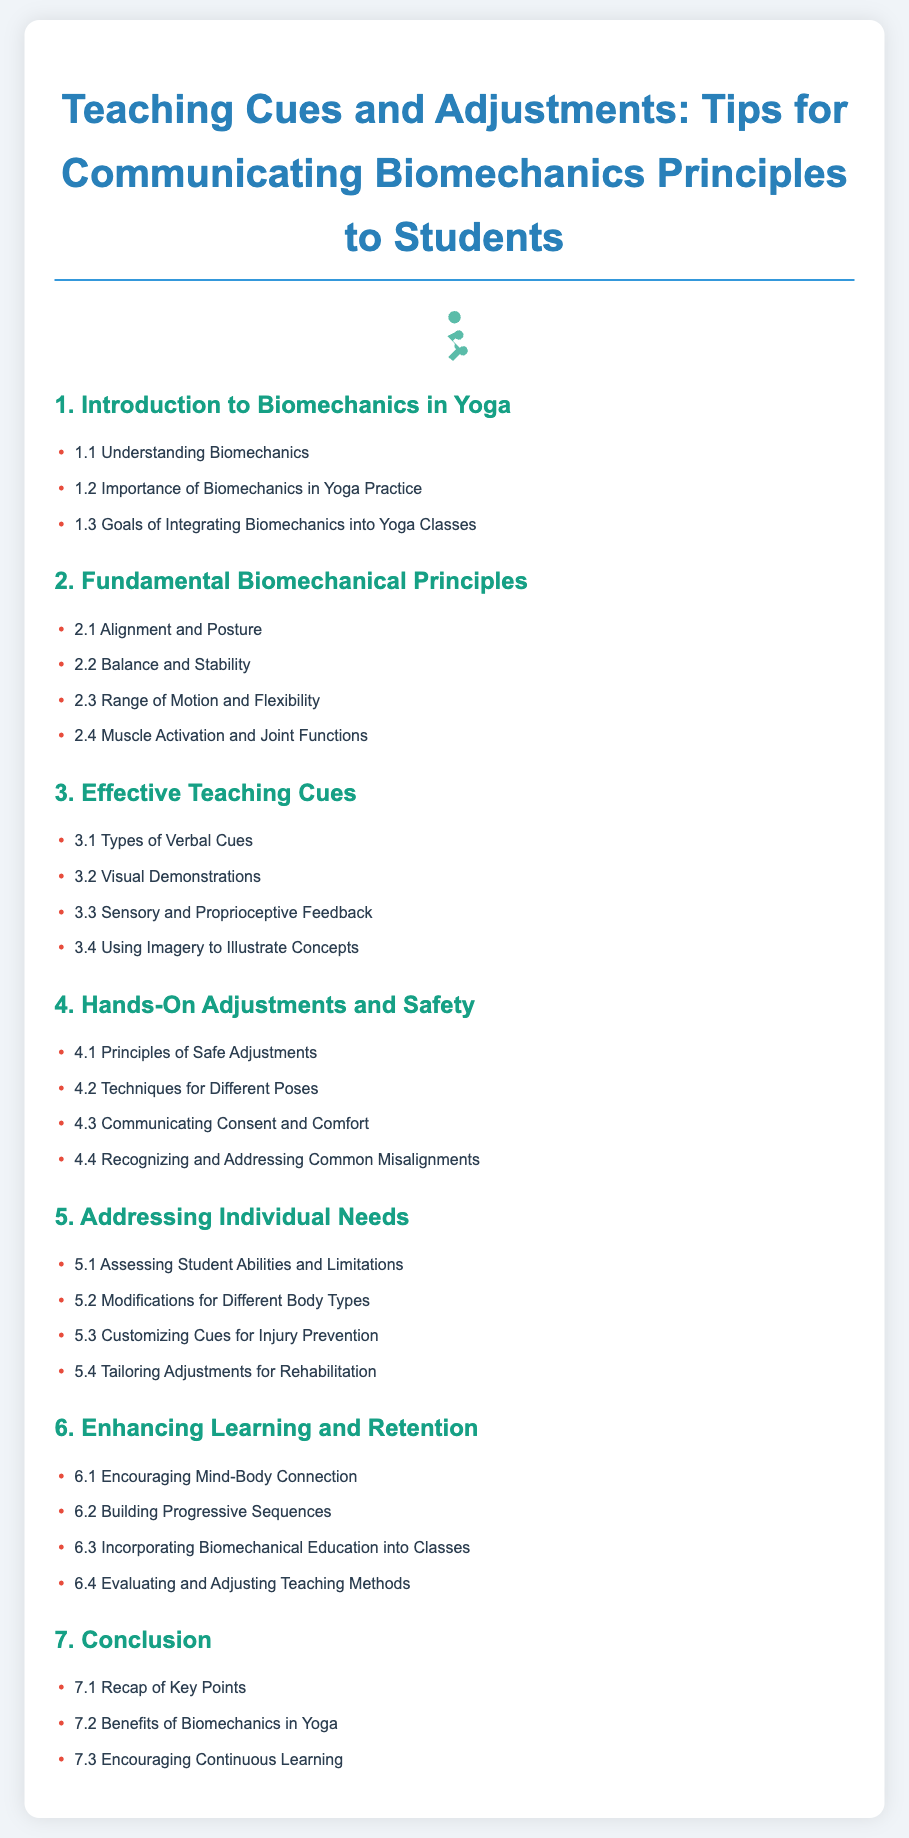What is the main focus of the document? The document focuses on teaching cues and adjustments in yoga, specifically how to communicate biomechanics principles to students.
Answer: Teaching Cues and Adjustments: Tips for Communicating Biomechanics Principles to Students How many fundamental biomechanical principles are covered? The section on fundamental biomechanical principles includes four specific areas, as listed in the document.
Answer: 4 What is the first topic under Effective Teaching Cues? The first topic under Effective Teaching Cues outlines different styles of verbal instruction for students during practice.
Answer: Types of Verbal Cues Which section addresses the safety of hands-on adjustments? This section emphasizes the importance of safe practices when making adjustments to students during yoga.
Answer: Hands-On Adjustments and Safety What is emphasized in the section titled "Addressing Individual Needs"? This section prioritizes understanding and considering the unique abilities and limitations of each student.
Answer: Assessing Student Abilities and Limitations How many tips are provided for enhancing learning and retention? The section on enhancing learning includes four specific strategies to help students retain information and concepts learned in class.
Answer: 4 What does the final section of the document recap? This section reviews the main takeaways from the document, highlighting the advantages of integrating biomechanics into yoga instruction.
Answer: Recap of Key Points 